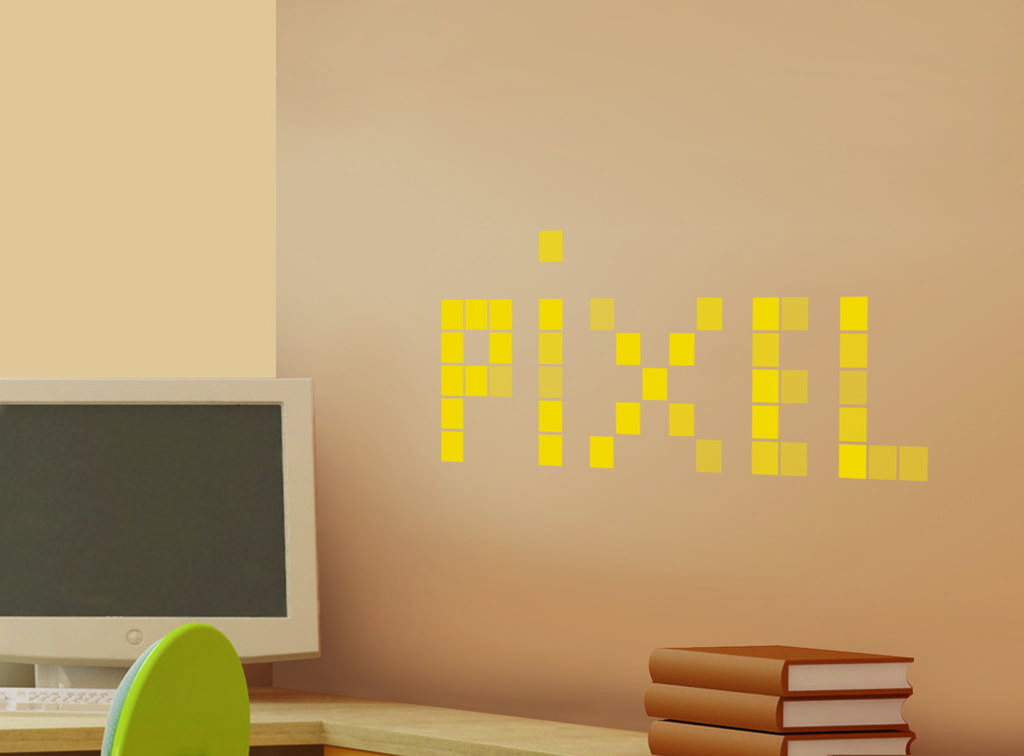In one or two sentences, can you explain what this image depicts? In the picture we can see a desk on it, we can see a monitor and keyboard which is white in color and beside of it, we can also see some books with brown cover to it and near to it there is a chair which is green in color and to the wall we can see a pixel written on it with yellow color. 